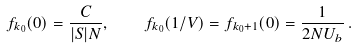<formula> <loc_0><loc_0><loc_500><loc_500>f _ { k _ { 0 } } ( 0 ) = \frac { C } { | S | N } , \quad f _ { k _ { 0 } } ( 1 / V ) = f _ { k _ { 0 } + 1 } ( 0 ) = \frac { 1 } { 2 N U _ { b } } \, .</formula> 